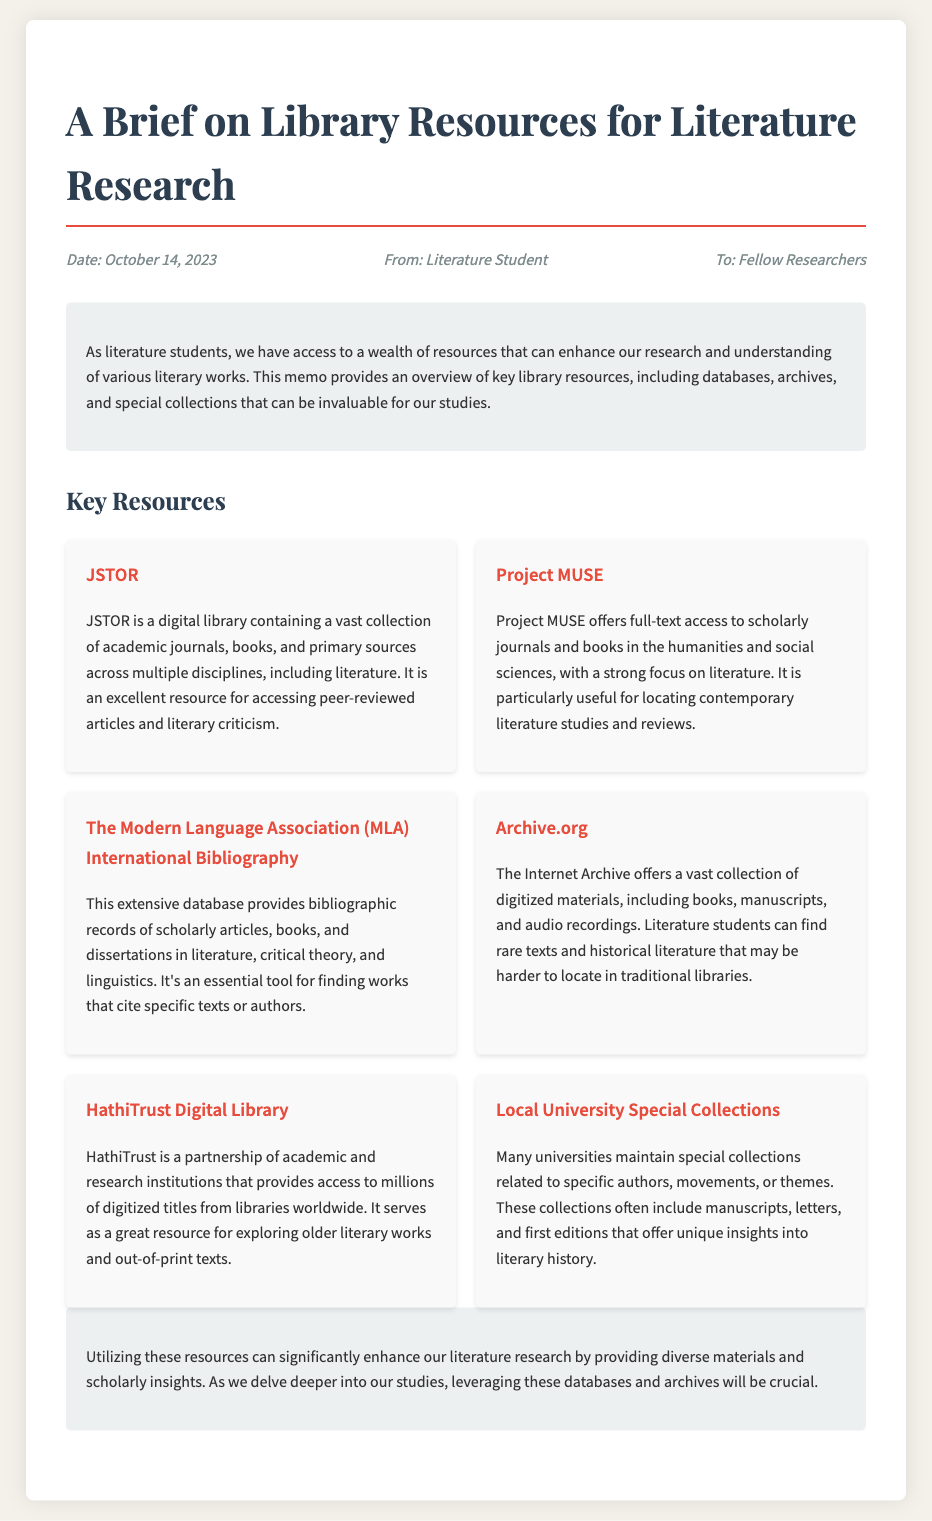what is the date of the memo? The date is explicitly stated in the meta section of the memo.
Answer: October 14, 2023 who is the memo addressed to? The memo specifies the recipients in the meta section.
Answer: Fellow Researchers what is the first database mentioned? The first resource listed under the Key Resources section is named here.
Answer: JSTOR how many databases are listed in the memo? The number of resources provided in the Key Resources section is counted.
Answer: Six which resource focuses on older literary works? The resource that is specifically mentioned for accessing older works is identified.
Answer: HathiTrust Digital Library what type of materials does Archive.org offer? The type of content provided by Archive.org is described in its overview.
Answer: Digitized materials why is using these resources important for literature students? The conclusion section highlights the significance of utilizing these resources.
Answer: Enhance research 